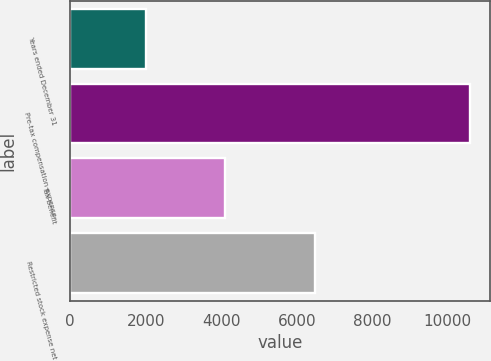<chart> <loc_0><loc_0><loc_500><loc_500><bar_chart><fcel>Years ended December 31<fcel>Pre-tax compensation expense<fcel>Tax benefit<fcel>Restricted stock expense net<nl><fcel>2014<fcel>10579<fcel>4094<fcel>6485<nl></chart> 